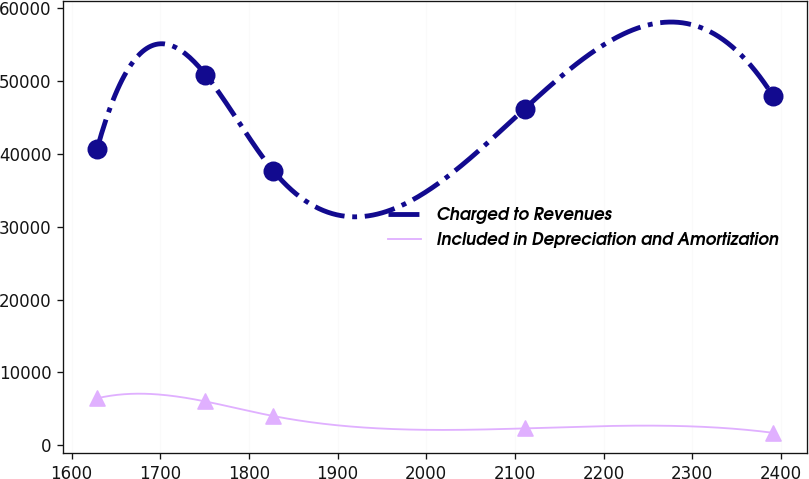Convert chart. <chart><loc_0><loc_0><loc_500><loc_500><line_chart><ecel><fcel>Charged to Revenues<fcel>Included in Depreciation and Amortization<nl><fcel>1628.62<fcel>40617.5<fcel>6461.16<nl><fcel>1750.97<fcel>50846.6<fcel>6027.8<nl><fcel>1827.23<fcel>37680.8<fcel>4035.78<nl><fcel>2111.19<fcel>46177.3<fcel>2337.82<nl><fcel>2391.25<fcel>47895.2<fcel>1729.62<nl></chart> 